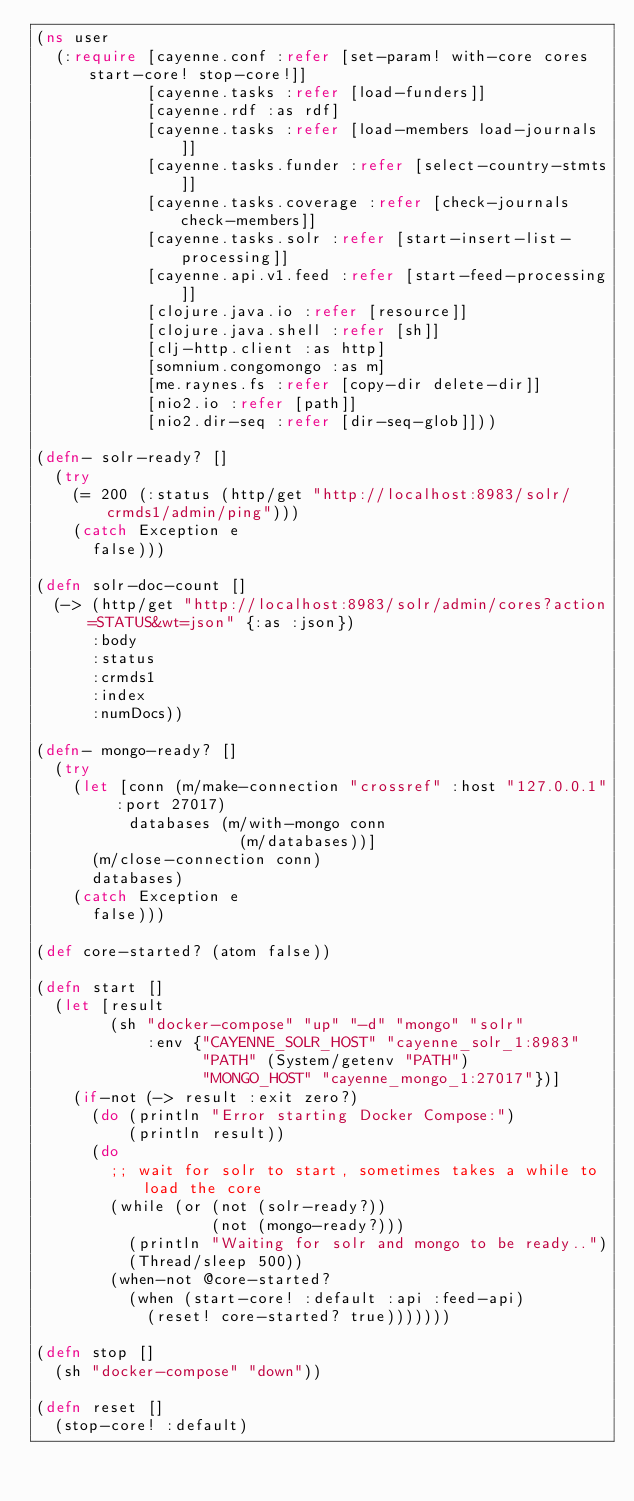<code> <loc_0><loc_0><loc_500><loc_500><_Clojure_>(ns user
  (:require [cayenne.conf :refer [set-param! with-core cores start-core! stop-core!]]
            [cayenne.tasks :refer [load-funders]]
            [cayenne.rdf :as rdf]
            [cayenne.tasks :refer [load-members load-journals]]
            [cayenne.tasks.funder :refer [select-country-stmts]]
            [cayenne.tasks.coverage :refer [check-journals check-members]]
            [cayenne.tasks.solr :refer [start-insert-list-processing]]
            [cayenne.api.v1.feed :refer [start-feed-processing]]
            [clojure.java.io :refer [resource]]
            [clojure.java.shell :refer [sh]]
            [clj-http.client :as http]
            [somnium.congomongo :as m]
            [me.raynes.fs :refer [copy-dir delete-dir]]
            [nio2.io :refer [path]]
            [nio2.dir-seq :refer [dir-seq-glob]]))

(defn- solr-ready? []
  (try
    (= 200 (:status (http/get "http://localhost:8983/solr/crmds1/admin/ping")))
    (catch Exception e
      false)))

(defn solr-doc-count []
  (-> (http/get "http://localhost:8983/solr/admin/cores?action=STATUS&wt=json" {:as :json})
      :body
      :status
      :crmds1
      :index
      :numDocs))

(defn- mongo-ready? []
  (try
    (let [conn (m/make-connection "crossref" :host "127.0.0.1" :port 27017)
          databases (m/with-mongo conn
                      (m/databases))]
      (m/close-connection conn)
      databases)
    (catch Exception e
      false)))

(def core-started? (atom false))

(defn start []
  (let [result
        (sh "docker-compose" "up" "-d" "mongo" "solr"
            :env {"CAYENNE_SOLR_HOST" "cayenne_solr_1:8983"
                  "PATH" (System/getenv "PATH")
                  "MONGO_HOST" "cayenne_mongo_1:27017"})]
    (if-not (-> result :exit zero?)
      (do (println "Error starting Docker Compose:")
          (println result))
      (do
        ;; wait for solr to start, sometimes takes a while to load the core
        (while (or (not (solr-ready?))
                   (not (mongo-ready?)))
          (println "Waiting for solr and mongo to be ready..")
          (Thread/sleep 500))
        (when-not @core-started?
          (when (start-core! :default :api :feed-api)
            (reset! core-started? true)))))))

(defn stop []
  (sh "docker-compose" "down"))

(defn reset []
  (stop-core! :default)</code> 